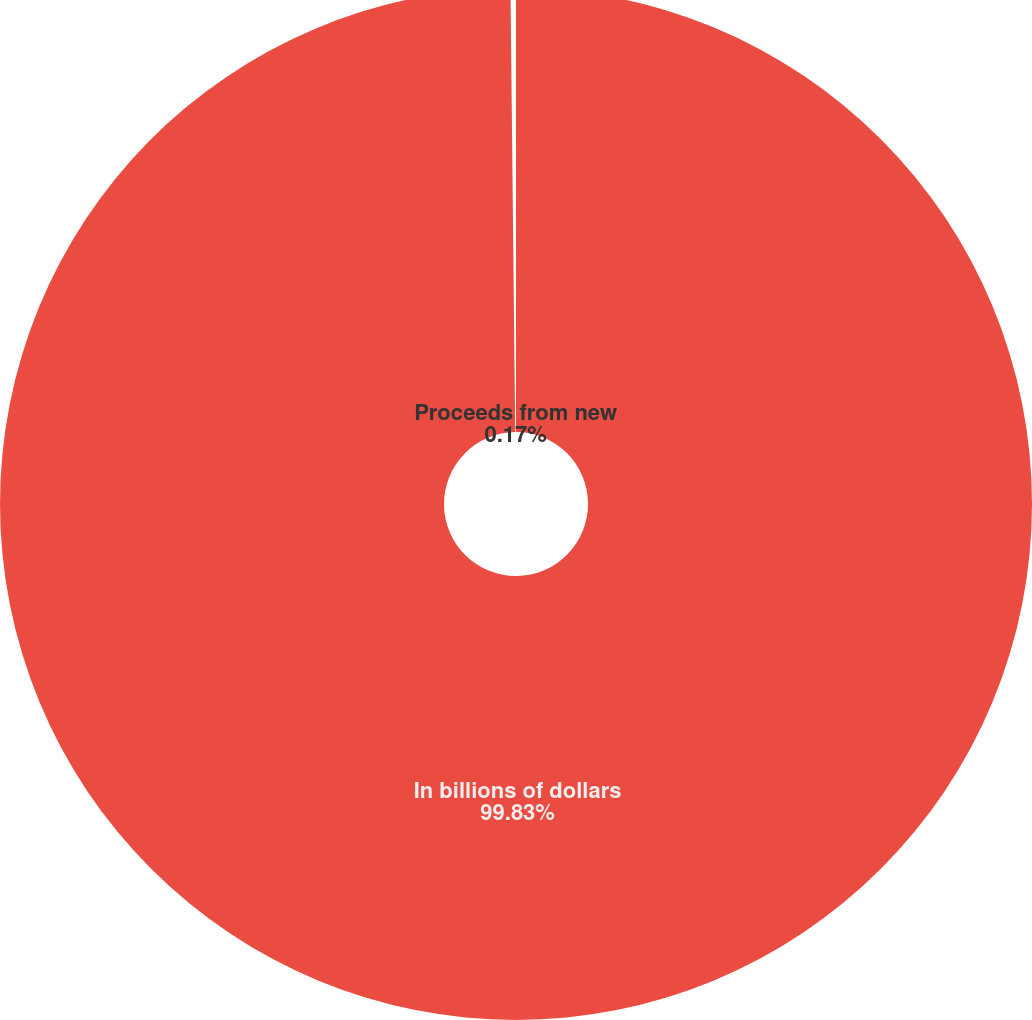<chart> <loc_0><loc_0><loc_500><loc_500><pie_chart><fcel>In billions of dollars<fcel>Proceeds from new<nl><fcel>99.83%<fcel>0.17%<nl></chart> 